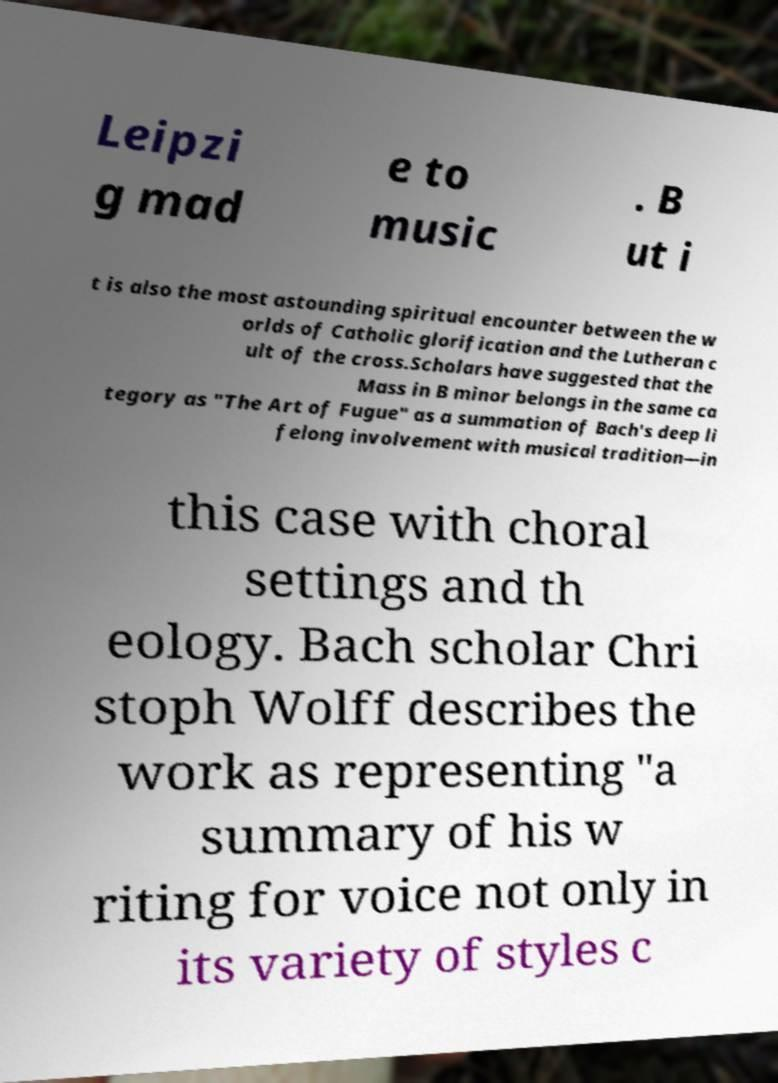Please read and relay the text visible in this image. What does it say? Leipzi g mad e to music . B ut i t is also the most astounding spiritual encounter between the w orlds of Catholic glorification and the Lutheran c ult of the cross.Scholars have suggested that the Mass in B minor belongs in the same ca tegory as "The Art of Fugue" as a summation of Bach's deep li felong involvement with musical tradition—in this case with choral settings and th eology. Bach scholar Chri stoph Wolff describes the work as representing "a summary of his w riting for voice not only in its variety of styles c 